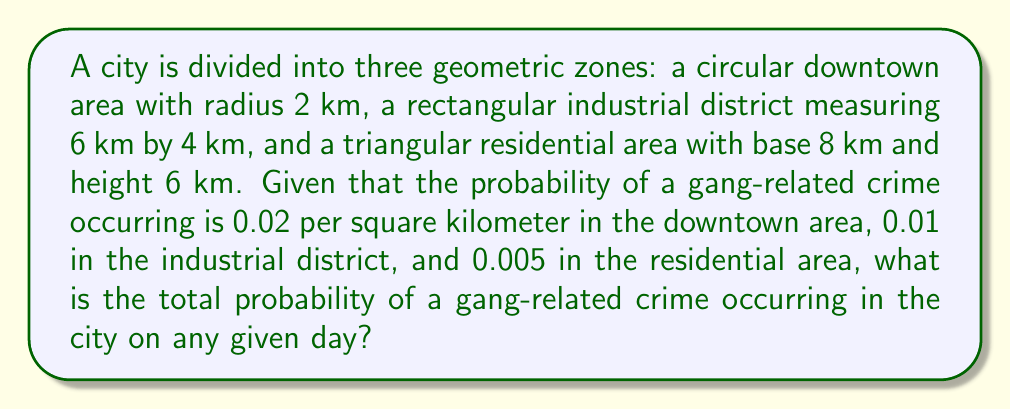Help me with this question. 1. Calculate the area of each zone:
   a. Downtown (circular): $A_d = \pi r^2 = \pi(2)^2 = 4\pi$ km²
   b. Industrial (rectangular): $A_i = l \times w = 6 \times 4 = 24$ km²
   c. Residential (triangular): $A_r = \frac{1}{2} \times b \times h = \frac{1}{2} \times 8 \times 6 = 24$ km²

2. Calculate the probability of a gang-related crime for each zone:
   a. Downtown: $P_d = 0.02 \times 4\pi = 0.08\pi$
   b. Industrial: $P_i = 0.01 \times 24 = 0.24$
   c. Residential: $P_r = 0.005 \times 24 = 0.12$

3. Sum the probabilities to get the total probability:
   $P_{total} = P_d + P_i + P_r = 0.08\pi + 0.24 + 0.12$

4. Simplify:
   $P_{total} = 0.08\pi + 0.36 \approx 0.6115$
Answer: $0.6115$ or $61.15\%$ 